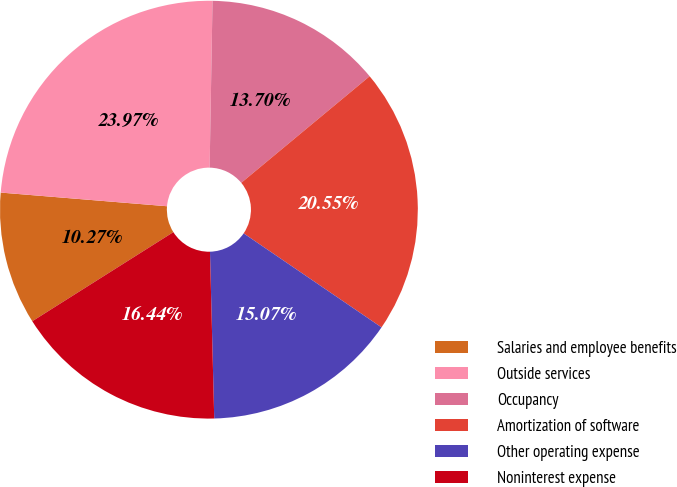Convert chart to OTSL. <chart><loc_0><loc_0><loc_500><loc_500><pie_chart><fcel>Salaries and employee benefits<fcel>Outside services<fcel>Occupancy<fcel>Amortization of software<fcel>Other operating expense<fcel>Noninterest expense<nl><fcel>10.27%<fcel>23.97%<fcel>13.7%<fcel>20.55%<fcel>15.07%<fcel>16.44%<nl></chart> 